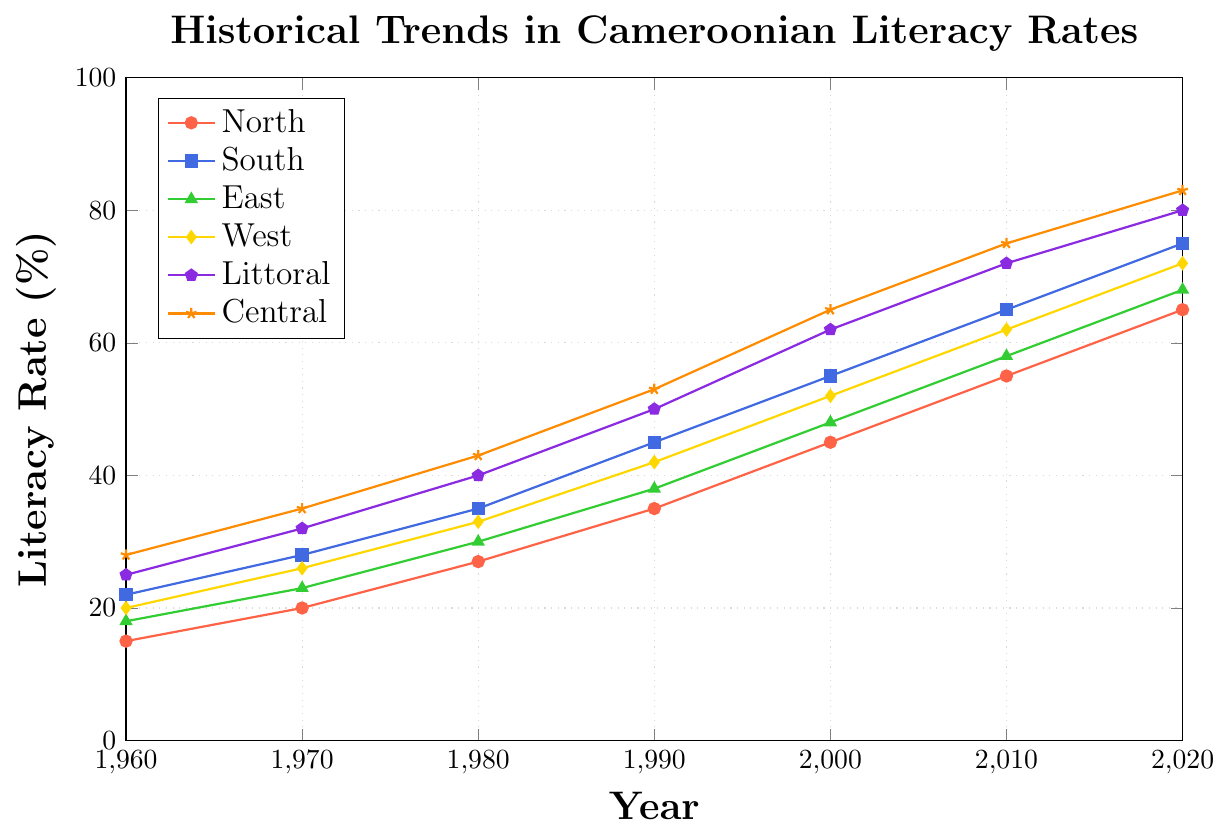What is the trend of literacy rates in the North region from 1960 to 2020? First, look at the North region's line, which is represented with red color and circular markers. The literacy rate in the North region increases from 15% in 1960 to 65% in 2020. Each decade shows an increasing trend.
Answer: Increasing Which region had the highest literacy rate in 2020, and what was the value? Look at the endpoints of each line in the year 2020 and find the highest value. The Central region (orange color with star markers) has the highest literacy rate of 83% in 2020.
Answer: Central, 83% What was the difference in literacy rates between the East and West regions in 1990? Identify the literacy rates in 1990 for both regions. The East region (green color with triangle markers) is at 38%, and the West region (yellow color with diamond markers) is at 42%. Subtract 38% from 42%.
Answer: 4% How many regions had a literacy rate of at least 70% in 2020? Check the values at the year 2020 for all regions and count how many are 70% or above. The South (75%), Central (83%), West (72%), East (68%), and Littoral (80%) regions. Therefore, South, Central, West, and Littoral meet the criteria.
Answer: 4 regions Which region saw the largest increase in literacy rate between 1960 and 2020? Calculate the difference for each region between 1960 and 2020. North region: 65-15=50, South region: 75-22=53, East region: 68-18=50, West region: 72-20=52, Littoral region: 80-25=55, Central region: 83-28=55. Compare all values; the Littoral and Central regions both saw the largest increase of 55%.
Answer: Littoral, Central In which decade did the South region achieve a literacy rate over 50%? Follow the South region's line (blue color with square markers) and find the decade where the literacy rate crosses 50%. It occurs between 1980 (35%) and 1990 (45%). The rate exceeds 50% by 2000 (55%).
Answer: Between 1990 and 2000 What is the average literacy rate of the North region across all years shown? Sum the literacy rates of the North region for each year: 15+20+27+35+45+55+65. Divide the sum by the number of years: 262/7.
Answer: 37.43% Compare the literacy rates of the Littoral and Central regions in 1980. Which one is higher and by how much? Look at the literacy rates for the Littoral (purple color with pentagon markers) and Central (orange color with star markers) in 1980. Littoral is at 40%, Central is at 43%. Subtract 40% from 43%.
Answer: Central, 3% What region exhibited the steadiest growth pattern in literacy rates from 1960 to 2020? Examine the slopes of the lines representing each region. The North region (red color with circular markers) shows a consistent and steady incline without abrupt changes.
Answer: North 